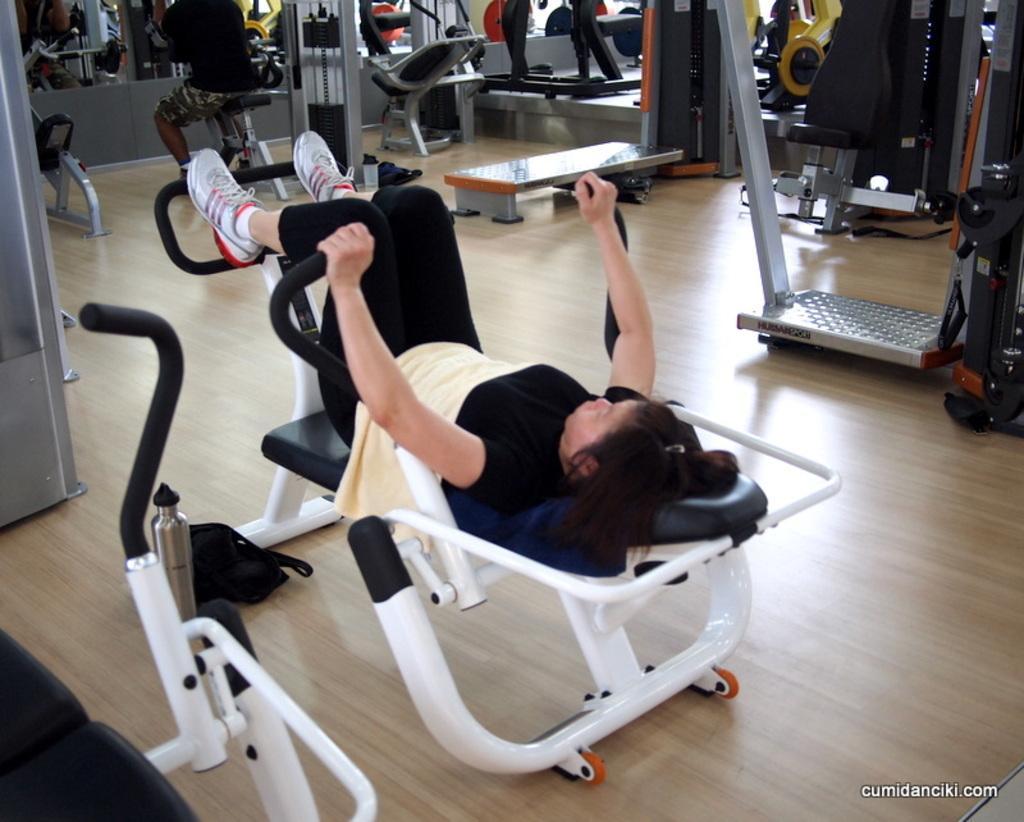Can you describe this image briefly? In this picture we can see gym equipment and the floor. We can see people working out. In the bottom right corner of the picture we can see watermark. 